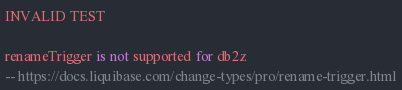Convert code to text. <code><loc_0><loc_0><loc_500><loc_500><_SQL_>INVALID TEST

renameTrigger is not supported for db2z
-- https://docs.liquibase.com/change-types/pro/rename-trigger.html</code> 